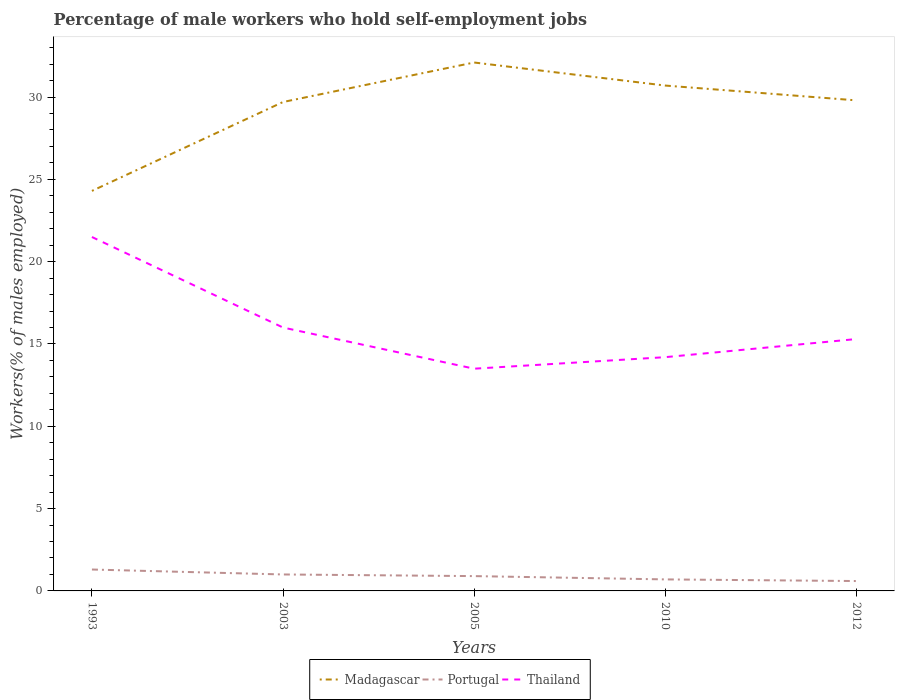Across all years, what is the maximum percentage of self-employed male workers in Madagascar?
Provide a succinct answer. 24.3. What is the total percentage of self-employed male workers in Portugal in the graph?
Ensure brevity in your answer.  0.2. What is the difference between the highest and the second highest percentage of self-employed male workers in Thailand?
Give a very brief answer. 8. What is the difference between the highest and the lowest percentage of self-employed male workers in Madagascar?
Provide a succinct answer. 4. How many lines are there?
Offer a very short reply. 3. How many years are there in the graph?
Make the answer very short. 5. Are the values on the major ticks of Y-axis written in scientific E-notation?
Offer a terse response. No. Does the graph contain any zero values?
Offer a very short reply. No. Does the graph contain grids?
Make the answer very short. No. How many legend labels are there?
Offer a terse response. 3. What is the title of the graph?
Offer a very short reply. Percentage of male workers who hold self-employment jobs. Does "Iceland" appear as one of the legend labels in the graph?
Keep it short and to the point. No. What is the label or title of the Y-axis?
Your response must be concise. Workers(% of males employed). What is the Workers(% of males employed) of Madagascar in 1993?
Your answer should be compact. 24.3. What is the Workers(% of males employed) in Portugal in 1993?
Ensure brevity in your answer.  1.3. What is the Workers(% of males employed) of Thailand in 1993?
Provide a succinct answer. 21.5. What is the Workers(% of males employed) of Madagascar in 2003?
Your response must be concise. 29.7. What is the Workers(% of males employed) in Portugal in 2003?
Your response must be concise. 1. What is the Workers(% of males employed) in Thailand in 2003?
Keep it short and to the point. 16. What is the Workers(% of males employed) of Madagascar in 2005?
Provide a succinct answer. 32.1. What is the Workers(% of males employed) in Portugal in 2005?
Provide a succinct answer. 0.9. What is the Workers(% of males employed) of Thailand in 2005?
Provide a succinct answer. 13.5. What is the Workers(% of males employed) in Madagascar in 2010?
Make the answer very short. 30.7. What is the Workers(% of males employed) of Portugal in 2010?
Offer a very short reply. 0.7. What is the Workers(% of males employed) of Thailand in 2010?
Ensure brevity in your answer.  14.2. What is the Workers(% of males employed) in Madagascar in 2012?
Keep it short and to the point. 29.8. What is the Workers(% of males employed) in Portugal in 2012?
Offer a terse response. 0.6. What is the Workers(% of males employed) in Thailand in 2012?
Your response must be concise. 15.3. Across all years, what is the maximum Workers(% of males employed) of Madagascar?
Your answer should be very brief. 32.1. Across all years, what is the maximum Workers(% of males employed) in Portugal?
Offer a terse response. 1.3. Across all years, what is the minimum Workers(% of males employed) of Madagascar?
Your answer should be very brief. 24.3. Across all years, what is the minimum Workers(% of males employed) in Portugal?
Provide a short and direct response. 0.6. Across all years, what is the minimum Workers(% of males employed) in Thailand?
Provide a succinct answer. 13.5. What is the total Workers(% of males employed) of Madagascar in the graph?
Your answer should be compact. 146.6. What is the total Workers(% of males employed) of Thailand in the graph?
Offer a very short reply. 80.5. What is the difference between the Workers(% of males employed) of Madagascar in 1993 and that in 2003?
Your answer should be very brief. -5.4. What is the difference between the Workers(% of males employed) in Thailand in 1993 and that in 2003?
Your answer should be very brief. 5.5. What is the difference between the Workers(% of males employed) of Madagascar in 1993 and that in 2005?
Your answer should be very brief. -7.8. What is the difference between the Workers(% of males employed) of Portugal in 1993 and that in 2005?
Your response must be concise. 0.4. What is the difference between the Workers(% of males employed) of Thailand in 1993 and that in 2005?
Make the answer very short. 8. What is the difference between the Workers(% of males employed) of Madagascar in 1993 and that in 2010?
Keep it short and to the point. -6.4. What is the difference between the Workers(% of males employed) in Portugal in 1993 and that in 2010?
Provide a succinct answer. 0.6. What is the difference between the Workers(% of males employed) of Madagascar in 1993 and that in 2012?
Offer a very short reply. -5.5. What is the difference between the Workers(% of males employed) in Thailand in 1993 and that in 2012?
Your answer should be compact. 6.2. What is the difference between the Workers(% of males employed) in Thailand in 2003 and that in 2010?
Your response must be concise. 1.8. What is the difference between the Workers(% of males employed) in Portugal in 2003 and that in 2012?
Make the answer very short. 0.4. What is the difference between the Workers(% of males employed) in Madagascar in 2005 and that in 2012?
Provide a succinct answer. 2.3. What is the difference between the Workers(% of males employed) in Thailand in 2005 and that in 2012?
Offer a terse response. -1.8. What is the difference between the Workers(% of males employed) in Madagascar in 2010 and that in 2012?
Provide a short and direct response. 0.9. What is the difference between the Workers(% of males employed) in Madagascar in 1993 and the Workers(% of males employed) in Portugal in 2003?
Keep it short and to the point. 23.3. What is the difference between the Workers(% of males employed) in Portugal in 1993 and the Workers(% of males employed) in Thailand in 2003?
Your answer should be very brief. -14.7. What is the difference between the Workers(% of males employed) of Madagascar in 1993 and the Workers(% of males employed) of Portugal in 2005?
Keep it short and to the point. 23.4. What is the difference between the Workers(% of males employed) of Madagascar in 1993 and the Workers(% of males employed) of Portugal in 2010?
Your response must be concise. 23.6. What is the difference between the Workers(% of males employed) in Madagascar in 1993 and the Workers(% of males employed) in Portugal in 2012?
Make the answer very short. 23.7. What is the difference between the Workers(% of males employed) of Madagascar in 1993 and the Workers(% of males employed) of Thailand in 2012?
Provide a short and direct response. 9. What is the difference between the Workers(% of males employed) of Madagascar in 2003 and the Workers(% of males employed) of Portugal in 2005?
Offer a very short reply. 28.8. What is the difference between the Workers(% of males employed) in Madagascar in 2003 and the Workers(% of males employed) in Thailand in 2005?
Ensure brevity in your answer.  16.2. What is the difference between the Workers(% of males employed) in Portugal in 2003 and the Workers(% of males employed) in Thailand in 2005?
Ensure brevity in your answer.  -12.5. What is the difference between the Workers(% of males employed) of Madagascar in 2003 and the Workers(% of males employed) of Portugal in 2010?
Ensure brevity in your answer.  29. What is the difference between the Workers(% of males employed) in Madagascar in 2003 and the Workers(% of males employed) in Thailand in 2010?
Provide a succinct answer. 15.5. What is the difference between the Workers(% of males employed) in Madagascar in 2003 and the Workers(% of males employed) in Portugal in 2012?
Offer a terse response. 29.1. What is the difference between the Workers(% of males employed) of Portugal in 2003 and the Workers(% of males employed) of Thailand in 2012?
Keep it short and to the point. -14.3. What is the difference between the Workers(% of males employed) in Madagascar in 2005 and the Workers(% of males employed) in Portugal in 2010?
Your response must be concise. 31.4. What is the difference between the Workers(% of males employed) of Madagascar in 2005 and the Workers(% of males employed) of Thailand in 2010?
Make the answer very short. 17.9. What is the difference between the Workers(% of males employed) of Madagascar in 2005 and the Workers(% of males employed) of Portugal in 2012?
Your response must be concise. 31.5. What is the difference between the Workers(% of males employed) of Portugal in 2005 and the Workers(% of males employed) of Thailand in 2012?
Ensure brevity in your answer.  -14.4. What is the difference between the Workers(% of males employed) in Madagascar in 2010 and the Workers(% of males employed) in Portugal in 2012?
Make the answer very short. 30.1. What is the difference between the Workers(% of males employed) of Madagascar in 2010 and the Workers(% of males employed) of Thailand in 2012?
Your answer should be very brief. 15.4. What is the difference between the Workers(% of males employed) in Portugal in 2010 and the Workers(% of males employed) in Thailand in 2012?
Give a very brief answer. -14.6. What is the average Workers(% of males employed) of Madagascar per year?
Provide a succinct answer. 29.32. What is the average Workers(% of males employed) in Portugal per year?
Offer a terse response. 0.9. What is the average Workers(% of males employed) in Thailand per year?
Provide a short and direct response. 16.1. In the year 1993, what is the difference between the Workers(% of males employed) in Portugal and Workers(% of males employed) in Thailand?
Your answer should be very brief. -20.2. In the year 2003, what is the difference between the Workers(% of males employed) in Madagascar and Workers(% of males employed) in Portugal?
Make the answer very short. 28.7. In the year 2003, what is the difference between the Workers(% of males employed) of Madagascar and Workers(% of males employed) of Thailand?
Your answer should be very brief. 13.7. In the year 2003, what is the difference between the Workers(% of males employed) of Portugal and Workers(% of males employed) of Thailand?
Your answer should be compact. -15. In the year 2005, what is the difference between the Workers(% of males employed) of Madagascar and Workers(% of males employed) of Portugal?
Provide a succinct answer. 31.2. In the year 2005, what is the difference between the Workers(% of males employed) in Portugal and Workers(% of males employed) in Thailand?
Offer a terse response. -12.6. In the year 2010, what is the difference between the Workers(% of males employed) of Madagascar and Workers(% of males employed) of Thailand?
Make the answer very short. 16.5. In the year 2010, what is the difference between the Workers(% of males employed) in Portugal and Workers(% of males employed) in Thailand?
Provide a short and direct response. -13.5. In the year 2012, what is the difference between the Workers(% of males employed) in Madagascar and Workers(% of males employed) in Portugal?
Provide a succinct answer. 29.2. In the year 2012, what is the difference between the Workers(% of males employed) of Portugal and Workers(% of males employed) of Thailand?
Keep it short and to the point. -14.7. What is the ratio of the Workers(% of males employed) of Madagascar in 1993 to that in 2003?
Ensure brevity in your answer.  0.82. What is the ratio of the Workers(% of males employed) in Portugal in 1993 to that in 2003?
Offer a very short reply. 1.3. What is the ratio of the Workers(% of males employed) in Thailand in 1993 to that in 2003?
Keep it short and to the point. 1.34. What is the ratio of the Workers(% of males employed) in Madagascar in 1993 to that in 2005?
Provide a short and direct response. 0.76. What is the ratio of the Workers(% of males employed) of Portugal in 1993 to that in 2005?
Your response must be concise. 1.44. What is the ratio of the Workers(% of males employed) in Thailand in 1993 to that in 2005?
Your response must be concise. 1.59. What is the ratio of the Workers(% of males employed) of Madagascar in 1993 to that in 2010?
Offer a very short reply. 0.79. What is the ratio of the Workers(% of males employed) in Portugal in 1993 to that in 2010?
Provide a succinct answer. 1.86. What is the ratio of the Workers(% of males employed) of Thailand in 1993 to that in 2010?
Ensure brevity in your answer.  1.51. What is the ratio of the Workers(% of males employed) in Madagascar in 1993 to that in 2012?
Ensure brevity in your answer.  0.82. What is the ratio of the Workers(% of males employed) of Portugal in 1993 to that in 2012?
Give a very brief answer. 2.17. What is the ratio of the Workers(% of males employed) in Thailand in 1993 to that in 2012?
Ensure brevity in your answer.  1.41. What is the ratio of the Workers(% of males employed) of Madagascar in 2003 to that in 2005?
Your answer should be very brief. 0.93. What is the ratio of the Workers(% of males employed) of Portugal in 2003 to that in 2005?
Give a very brief answer. 1.11. What is the ratio of the Workers(% of males employed) of Thailand in 2003 to that in 2005?
Offer a terse response. 1.19. What is the ratio of the Workers(% of males employed) of Madagascar in 2003 to that in 2010?
Your answer should be very brief. 0.97. What is the ratio of the Workers(% of males employed) of Portugal in 2003 to that in 2010?
Your answer should be very brief. 1.43. What is the ratio of the Workers(% of males employed) in Thailand in 2003 to that in 2010?
Your answer should be very brief. 1.13. What is the ratio of the Workers(% of males employed) of Madagascar in 2003 to that in 2012?
Provide a short and direct response. 1. What is the ratio of the Workers(% of males employed) in Portugal in 2003 to that in 2012?
Ensure brevity in your answer.  1.67. What is the ratio of the Workers(% of males employed) of Thailand in 2003 to that in 2012?
Make the answer very short. 1.05. What is the ratio of the Workers(% of males employed) in Madagascar in 2005 to that in 2010?
Provide a short and direct response. 1.05. What is the ratio of the Workers(% of males employed) of Thailand in 2005 to that in 2010?
Offer a terse response. 0.95. What is the ratio of the Workers(% of males employed) in Madagascar in 2005 to that in 2012?
Offer a terse response. 1.08. What is the ratio of the Workers(% of males employed) of Portugal in 2005 to that in 2012?
Provide a short and direct response. 1.5. What is the ratio of the Workers(% of males employed) of Thailand in 2005 to that in 2012?
Make the answer very short. 0.88. What is the ratio of the Workers(% of males employed) in Madagascar in 2010 to that in 2012?
Ensure brevity in your answer.  1.03. What is the ratio of the Workers(% of males employed) of Thailand in 2010 to that in 2012?
Offer a very short reply. 0.93. What is the difference between the highest and the second highest Workers(% of males employed) of Madagascar?
Keep it short and to the point. 1.4. What is the difference between the highest and the second highest Workers(% of males employed) in Thailand?
Your answer should be very brief. 5.5. What is the difference between the highest and the lowest Workers(% of males employed) of Madagascar?
Give a very brief answer. 7.8. What is the difference between the highest and the lowest Workers(% of males employed) in Portugal?
Give a very brief answer. 0.7. What is the difference between the highest and the lowest Workers(% of males employed) of Thailand?
Keep it short and to the point. 8. 